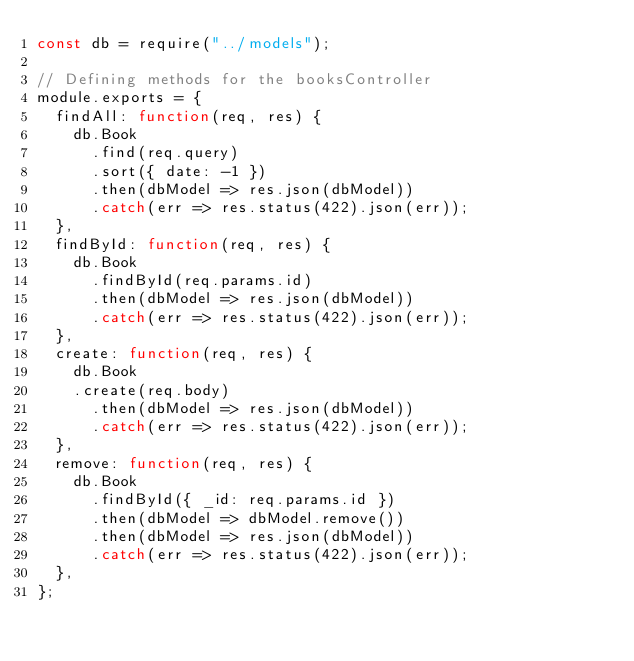Convert code to text. <code><loc_0><loc_0><loc_500><loc_500><_JavaScript_>const db = require("../models");

// Defining methods for the booksController
module.exports = {
  findAll: function(req, res) {
    db.Book
      .find(req.query)
      .sort({ date: -1 })
      .then(dbModel => res.json(dbModel))
      .catch(err => res.status(422).json(err));
  },
  findById: function(req, res) {
    db.Book
      .findById(req.params.id)
      .then(dbModel => res.json(dbModel))
      .catch(err => res.status(422).json(err));
  },
  create: function(req, res) {
    db.Book
    .create(req.body)
      .then(dbModel => res.json(dbModel))
      .catch(err => res.status(422).json(err));
  },
  remove: function(req, res) {
    db.Book
      .findById({ _id: req.params.id })
      .then(dbModel => dbModel.remove())
      .then(dbModel => res.json(dbModel))
      .catch(err => res.status(422).json(err));
  },
};
</code> 